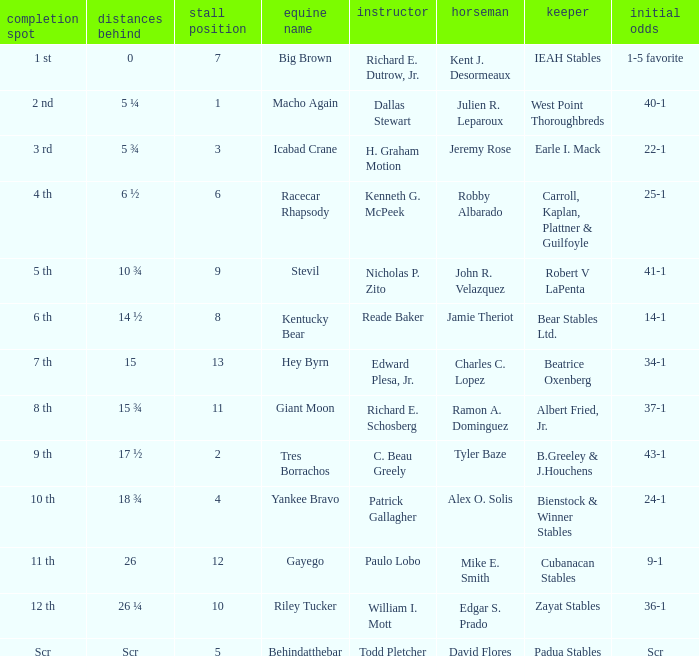What's the post position when the lengths behind is 0? 7.0. 